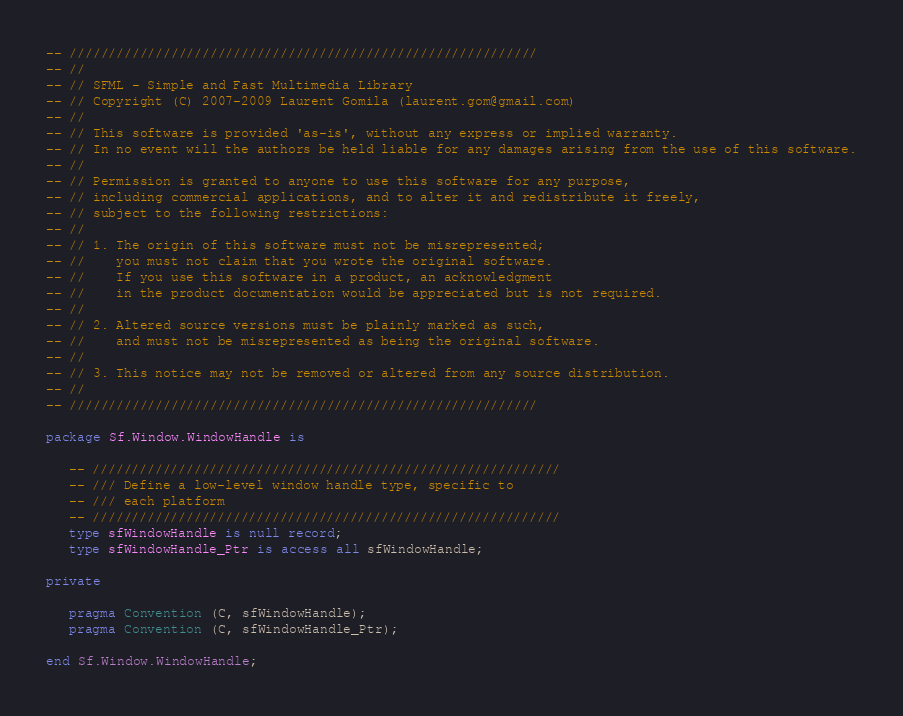<code> <loc_0><loc_0><loc_500><loc_500><_Ada_>-- ////////////////////////////////////////////////////////////
-- //
-- // SFML - Simple and Fast Multimedia Library
-- // Copyright (C) 2007-2009 Laurent Gomila (laurent.gom@gmail.com)
-- //
-- // This software is provided 'as-is', without any express or implied warranty.
-- // In no event will the authors be held liable for any damages arising from the use of this software.
-- //
-- // Permission is granted to anyone to use this software for any purpose,
-- // including commercial applications, and to alter it and redistribute it freely,
-- // subject to the following restrictions:
-- //
-- // 1. The origin of this software must not be misrepresented;
-- //    you must not claim that you wrote the original software.
-- //    If you use this software in a product, an acknowledgment
-- //    in the product documentation would be appreciated but is not required.
-- //
-- // 2. Altered source versions must be plainly marked as such,
-- //    and must not be misrepresented as being the original software.
-- //
-- // 3. This notice may not be removed or altered from any source distribution.
-- //
-- ////////////////////////////////////////////////////////////

package Sf.Window.WindowHandle is

   -- ////////////////////////////////////////////////////////////
   -- /// Define a low-level window handle type, specific to
   -- /// each platform
   -- ////////////////////////////////////////////////////////////
   type sfWindowHandle is null record;
   type sfWindowHandle_Ptr is access all sfWindowHandle;

private

   pragma Convention (C, sfWindowHandle);
   pragma Convention (C, sfWindowHandle_Ptr);

end Sf.Window.WindowHandle;
</code> 